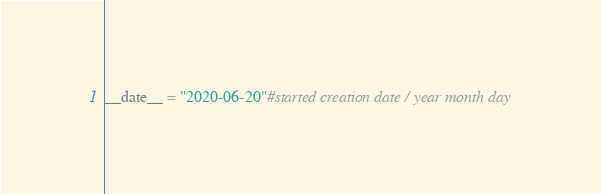<code> <loc_0><loc_0><loc_500><loc_500><_Python_>__date__ = "2020-06-20"#started creation date / year month day</code> 